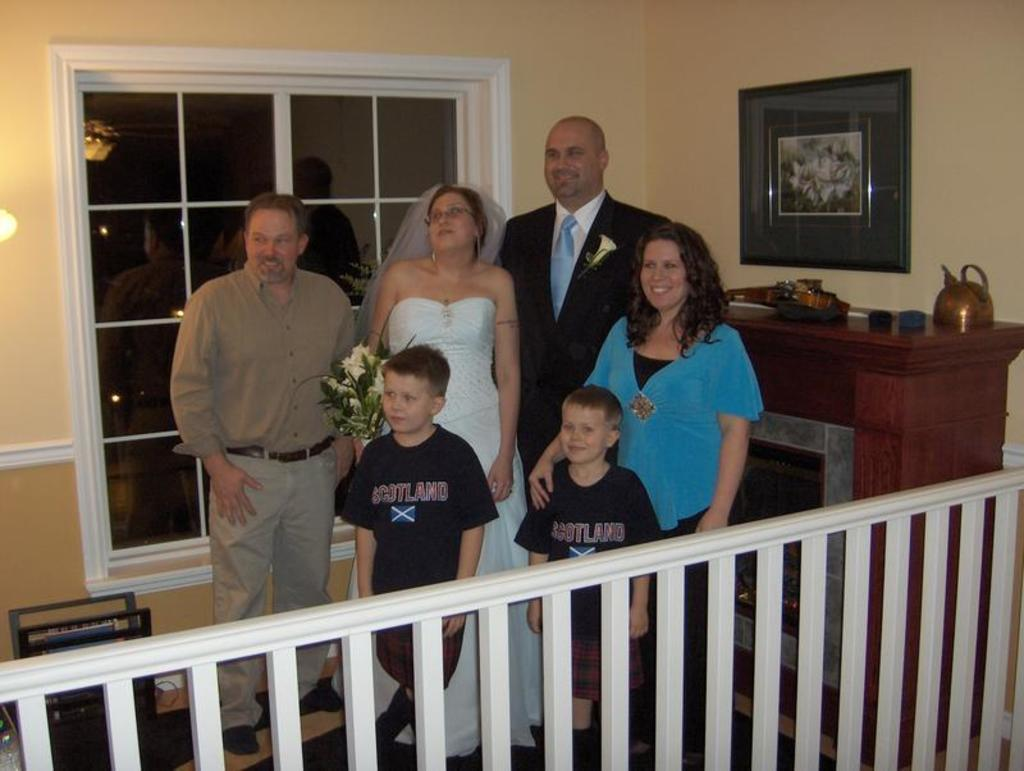What is happening in the image? There are people standing in the image. What can be seen on a table in the image? There are objects on a table in the image. What is visible on the wall in the background of the image? There is a frame on a wall in the background of the image. What is visible through the window in the background of the image? There is light in the background of the image. What is present in the image that separates spaces or areas? There is a fence in the image. How does the fence run in the image? The fence does not run in the image; it is stationary and separates spaces or areas. What type of bit is present in the image? There is no bit present in the image. 